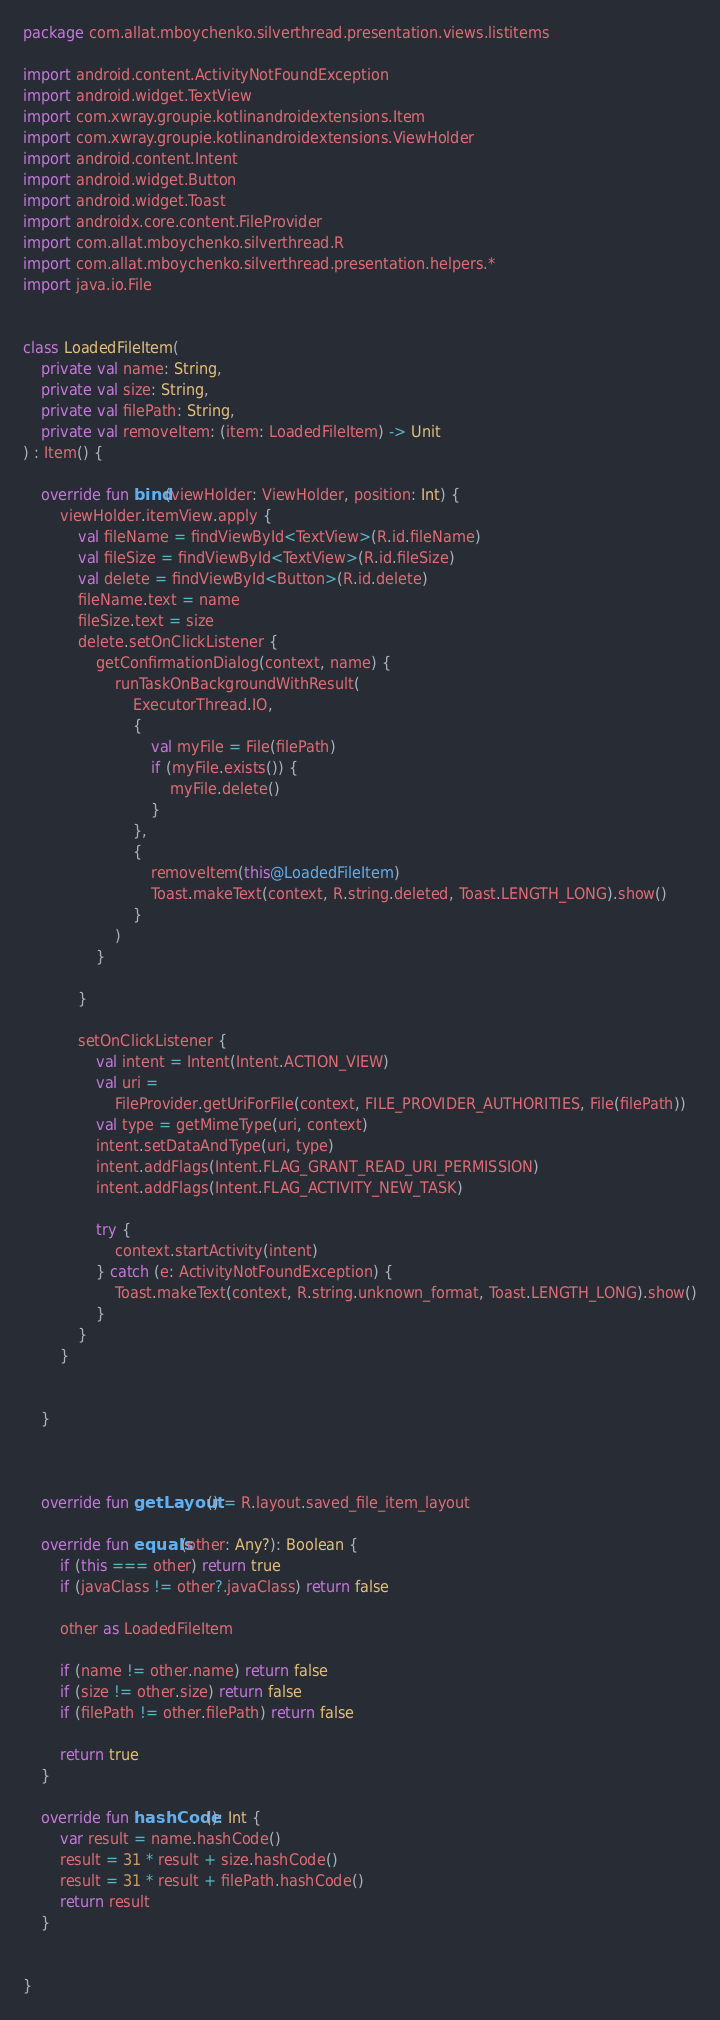<code> <loc_0><loc_0><loc_500><loc_500><_Kotlin_>package com.allat.mboychenko.silverthread.presentation.views.listitems

import android.content.ActivityNotFoundException
import android.widget.TextView
import com.xwray.groupie.kotlinandroidextensions.Item
import com.xwray.groupie.kotlinandroidextensions.ViewHolder
import android.content.Intent
import android.widget.Button
import android.widget.Toast
import androidx.core.content.FileProvider
import com.allat.mboychenko.silverthread.R
import com.allat.mboychenko.silverthread.presentation.helpers.*
import java.io.File


class LoadedFileItem(
    private val name: String,
    private val size: String,
    private val filePath: String,
    private val removeItem: (item: LoadedFileItem) -> Unit
) : Item() {

    override fun bind(viewHolder: ViewHolder, position: Int) {
        viewHolder.itemView.apply {
            val fileName = findViewById<TextView>(R.id.fileName)
            val fileSize = findViewById<TextView>(R.id.fileSize)
            val delete = findViewById<Button>(R.id.delete)
            fileName.text = name
            fileSize.text = size
            delete.setOnClickListener {
                getConfirmationDialog(context, name) {
                    runTaskOnBackgroundWithResult(
                        ExecutorThread.IO,
                        {
                            val myFile = File(filePath)
                            if (myFile.exists()) {
                                myFile.delete()
                            }
                        },
                        {
                            removeItem(this@LoadedFileItem)
                            Toast.makeText(context, R.string.deleted, Toast.LENGTH_LONG).show()
                        }
                    )
                }

            }

            setOnClickListener {
                val intent = Intent(Intent.ACTION_VIEW)
                val uri =
                    FileProvider.getUriForFile(context, FILE_PROVIDER_AUTHORITIES, File(filePath))
                val type = getMimeType(uri, context)
                intent.setDataAndType(uri, type)
                intent.addFlags(Intent.FLAG_GRANT_READ_URI_PERMISSION)
                intent.addFlags(Intent.FLAG_ACTIVITY_NEW_TASK)

                try {
                    context.startActivity(intent)
                } catch (e: ActivityNotFoundException) {
                    Toast.makeText(context, R.string.unknown_format, Toast.LENGTH_LONG).show()
                }
            }
        }


    }



    override fun getLayout() = R.layout.saved_file_item_layout

    override fun equals(other: Any?): Boolean {
        if (this === other) return true
        if (javaClass != other?.javaClass) return false

        other as LoadedFileItem

        if (name != other.name) return false
        if (size != other.size) return false
        if (filePath != other.filePath) return false

        return true
    }

    override fun hashCode(): Int {
        var result = name.hashCode()
        result = 31 * result + size.hashCode()
        result = 31 * result + filePath.hashCode()
        return result
    }


}</code> 